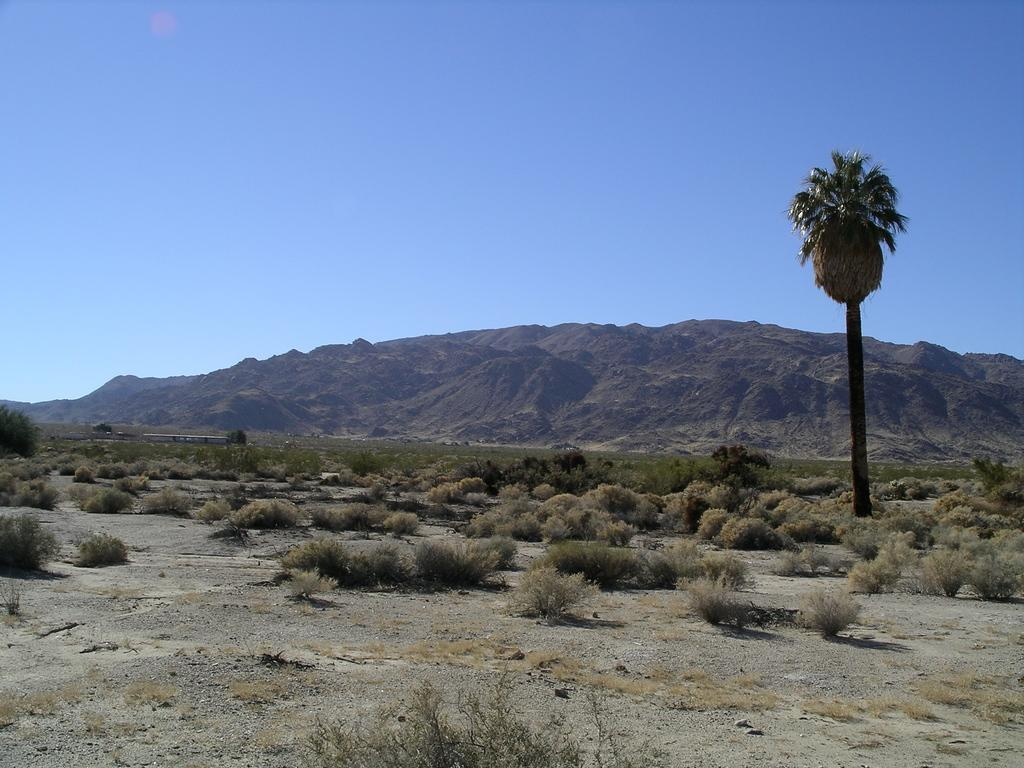What type of vegetation can be seen in the image? There are plants and a tree in the image. What type of natural landform is visible in the image? There are mountains in the image. What part of the natural environment is visible in the image? The sky is visible in the image. What time of day is the market open in the image? There is no market present in the image, so it is not possible to determine the time of day or when the market might be open. 